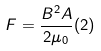Convert formula to latex. <formula><loc_0><loc_0><loc_500><loc_500>F = \frac { B ^ { 2 } A } { 2 \mu _ { 0 } } ( 2 )</formula> 